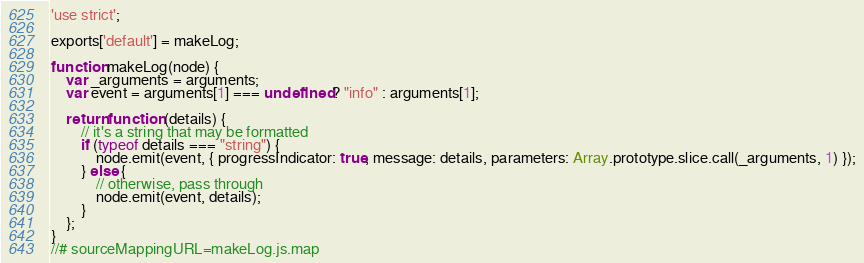Convert code to text. <code><loc_0><loc_0><loc_500><loc_500><_JavaScript_>'use strict';

exports['default'] = makeLog;

function makeLog(node) {
	var _arguments = arguments;
	var event = arguments[1] === undefined ? "info" : arguments[1];

	return function (details) {
		// it's a string that may be formatted
		if (typeof details === "string") {
			node.emit(event, { progressIndicator: true, message: details, parameters: Array.prototype.slice.call(_arguments, 1) });
		} else {
			// otherwise, pass through
			node.emit(event, details);
		}
	};
}
//# sourceMappingURL=makeLog.js.map
</code> 